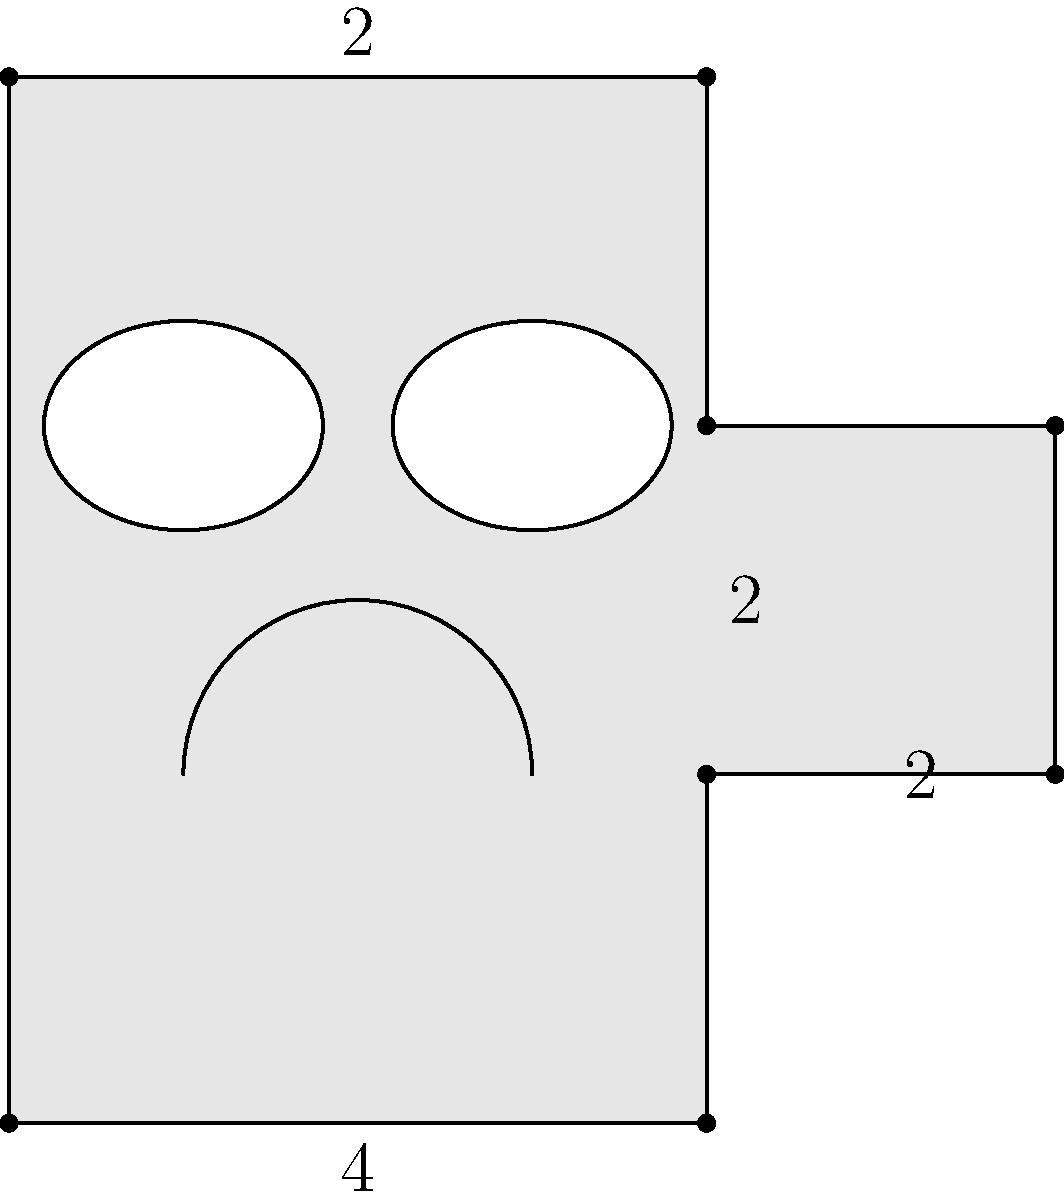As a master of traditional Chinese opera, you're designing a new mask for your upcoming performance. The mask's shape is composed of a rectangle with a small rectangle extending from its right side, as shown in the diagram. Two circular eye holes and a semicircular mouth opening are cut out. If the main rectangle measures 4 units wide and 6 units tall, and the extending rectangle is 2 units wide and 2 units tall, what is the total area of the mask in square units? (Assume π = 3.14 for calculations) Let's approach this step-by-step:

1) First, calculate the area of the main rectangular part:
   $A_1 = 4 \times 6 = 24$ square units

2) Add the area of the extending rectangle:
   $A_2 = 2 \times 2 = 4$ square units

3) Total area of the base shape:
   $A_{base} = A_1 + A_2 = 24 + 4 = 28$ square units

4) Now, calculate the areas to be subtracted:

   a) For the eye holes (which are ellipses):
      Area of an ellipse = $\pi ab$, where $a$ and $b$ are the semi-major and semi-minor axes.
      From the diagram, we can estimate $a = 0.8/2 = 0.4$ and $b = 0.6/2 = 0.3$
      Area of one eye = $\pi(0.4)(0.3) = 0.12\pi \approx 0.3768$ square units
      Area of both eyes = $2(0.3768) = 0.7536$ square units

   b) For the mouth (which is a semicircle):
      Area of a semicircle = $\frac{1}{2}\pi r^2$
      The radius appears to be about 1 unit
      Area of mouth = $\frac{1}{2}\pi(1)^2 = \frac{\pi}{2} \approx 1.57$ square units

5) Total area to be subtracted:
   $A_{subtract} = 0.7536 + 1.57 = 2.3236$ square units

6) Final area of the mask:
   $A_{mask} = A_{base} - A_{subtract} = 28 - 2.3236 = 25.6764$ square units
Answer: $25.68$ square units 